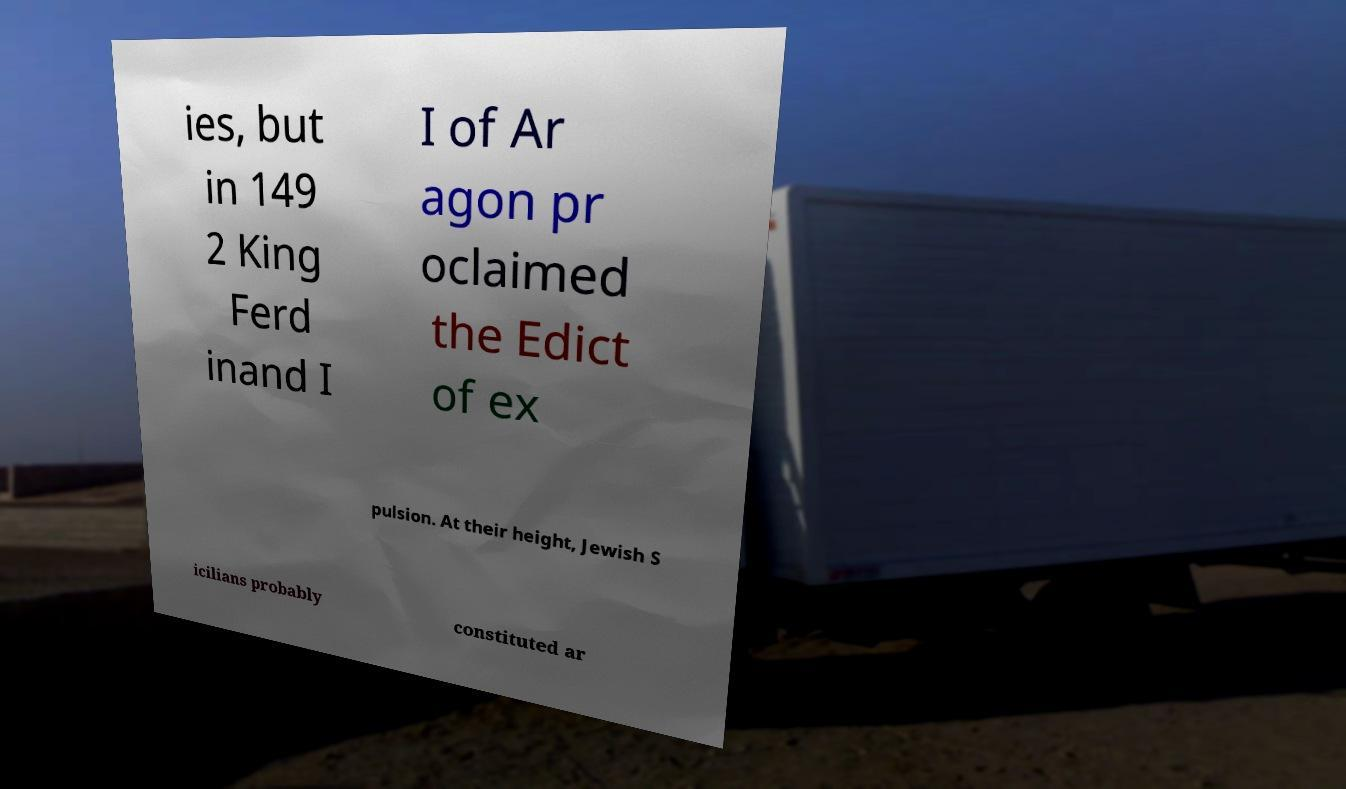Could you extract and type out the text from this image? ies, but in 149 2 King Ferd inand I I of Ar agon pr oclaimed the Edict of ex pulsion. At their height, Jewish S icilians probably constituted ar 